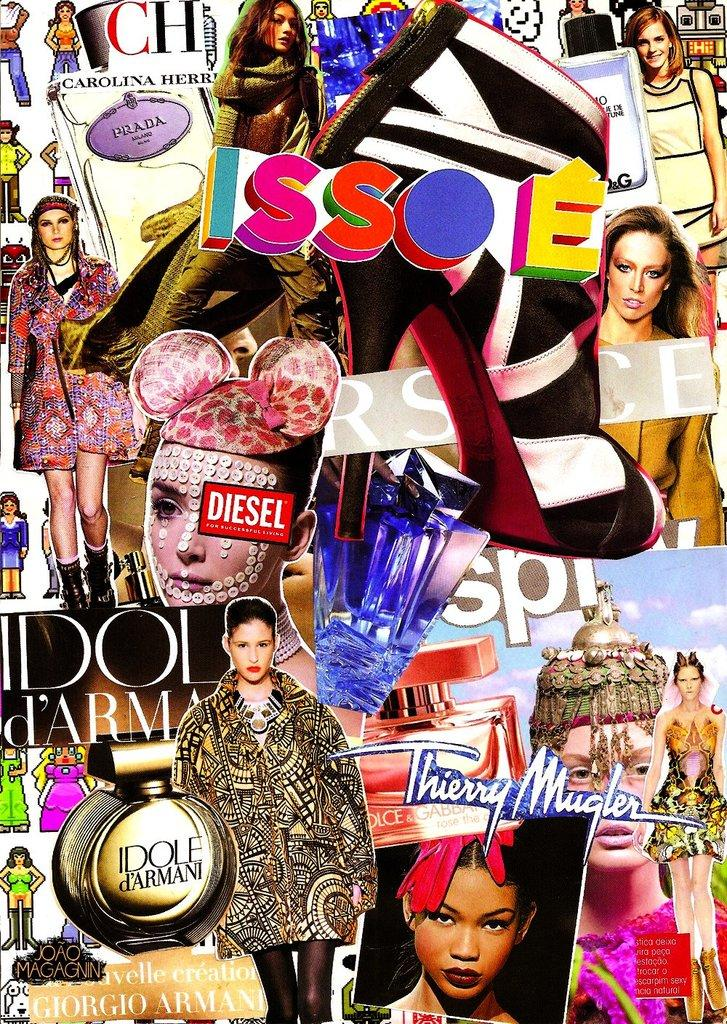<image>
Offer a succinct explanation of the picture presented. A montage of fashion models is messily splashed across the cover of Issoe magazine. 